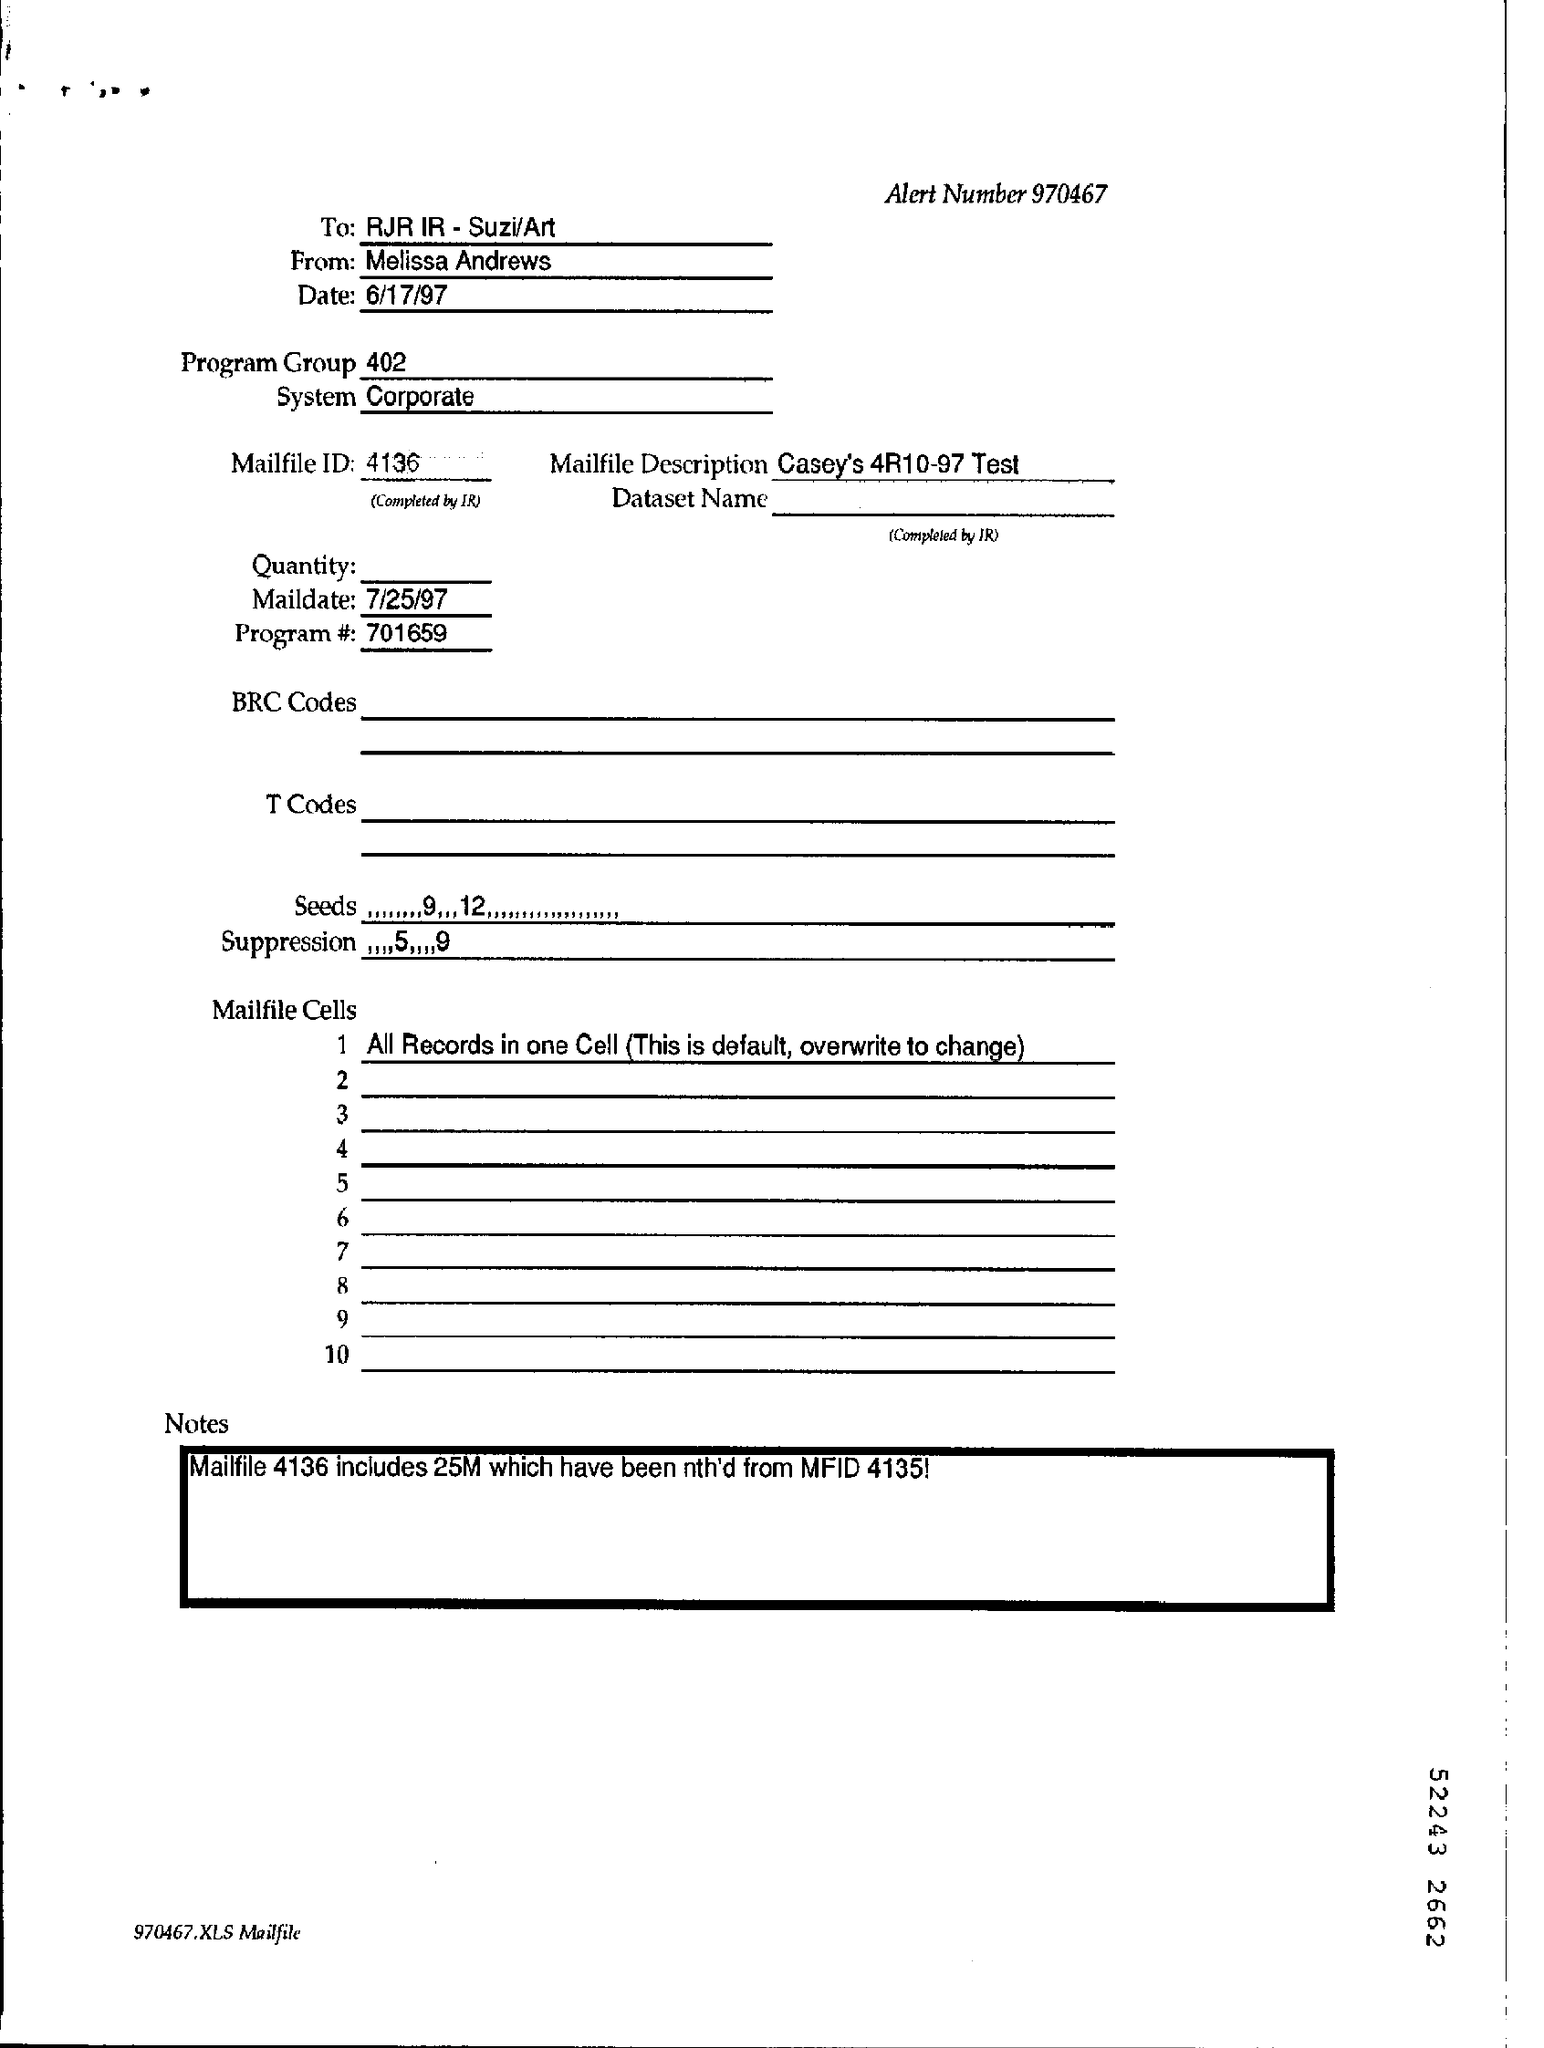What is the Alert Number ?
Ensure brevity in your answer.  970467. Who sent this ?
Ensure brevity in your answer.  Melissa Andrews. Who is the recipient ?
Ensure brevity in your answer.  RJR IR - Suzi/Art. What is the date mentioned in the top of the document ?
Your answer should be very brief. 6/17/97. What is the Mail Date ?
Make the answer very short. 7/25/97. What is written in the System Field ?
Ensure brevity in your answer.  Corporate. What is the Mailfile ID ?
Offer a very short reply. 4136. What is written in the Mailfile Description Filed ?
Provide a short and direct response. Casey's 4R10-97 Test. What is the Program Number ?
Ensure brevity in your answer.  701659. What is written in the Program Group ?
Offer a very short reply. 402. 